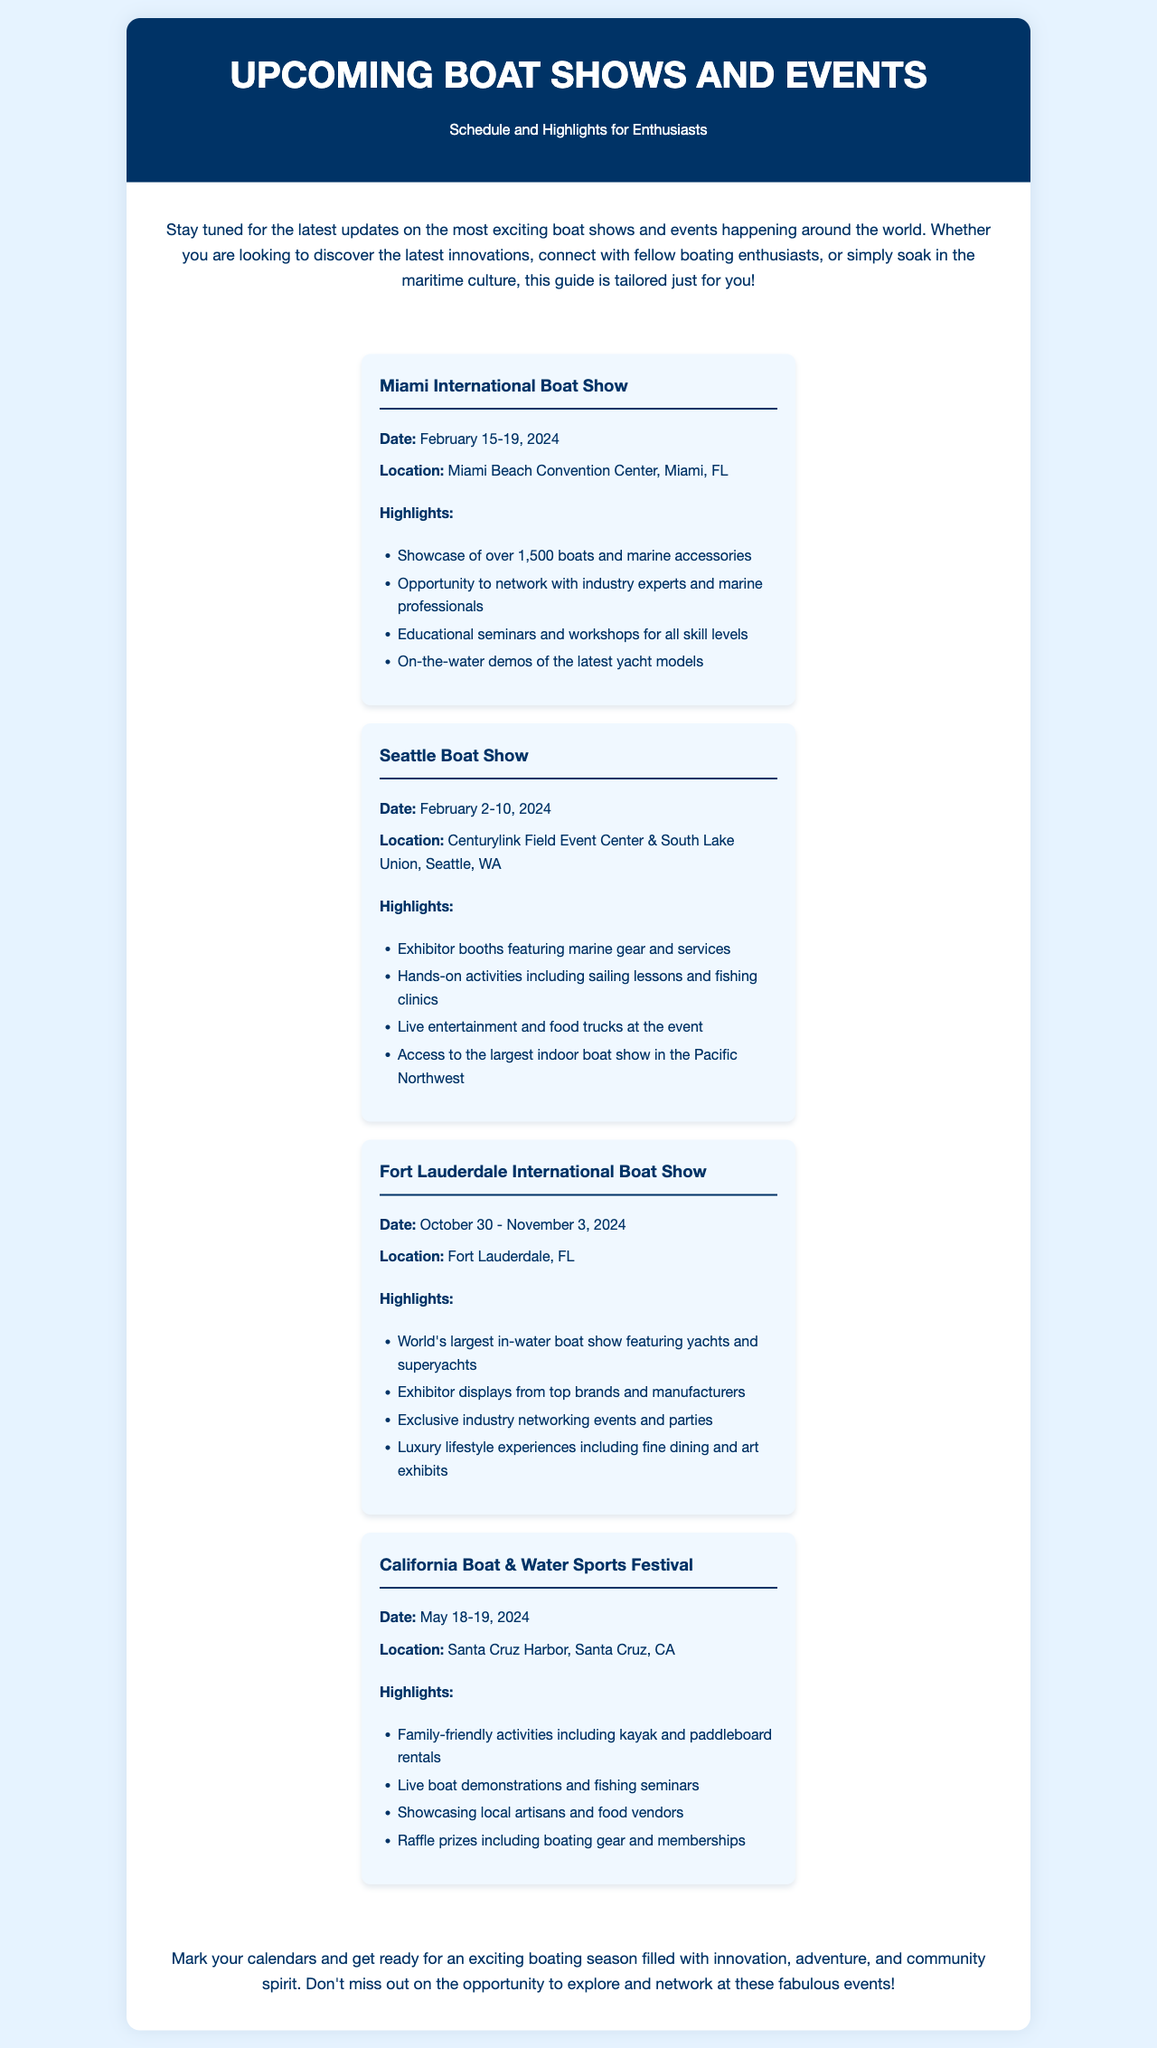what is the date of the Miami International Boat Show? The document states that the Miami International Boat Show will take place from February 15-19, 2024.
Answer: February 15-19, 2024 where is the Seattle Boat Show held? According to the document, the Seattle Boat Show is held at Centurylink Field Event Center & South Lake Union, Seattle, WA.
Answer: Centurylink Field Event Center & South Lake Union, Seattle, WA how many boats will be showcased at the Miami International Boat Show? The document mentions that the Miami International Boat Show will showcase over 1,500 boats.
Answer: over 1,500 boats what type of events occur at the Fort Lauderdale International Boat Show? The highlights section provides details about exclusive industry networking events and luxury lifestyle experiences featured at the show.
Answer: exclusive industry networking events and luxury lifestyle experiences what unique feature does the California Boat & Water Sports Festival offer for families? The document indicates that family-friendly activities including kayak and paddleboard rentals will be available at the festival.
Answer: kayak and paddleboard rentals which boat show is known as the world's largest in-water boat show? Based on the document, the Fort Lauderdale International Boat Show is referred to as the world's largest in-water boat show.
Answer: Fort Lauderdale International Boat Show when is the California Boat & Water Sports Festival? As stated in the document, the festival takes place on May 18-19, 2024.
Answer: May 18-19, 2024 what kind of activities can you expect at the Seattle Boat Show? The highlights list includes hands-on activities such as sailing lessons and fishing clinics at the Seattle Boat Show.
Answer: sailing lessons and fishing clinics 